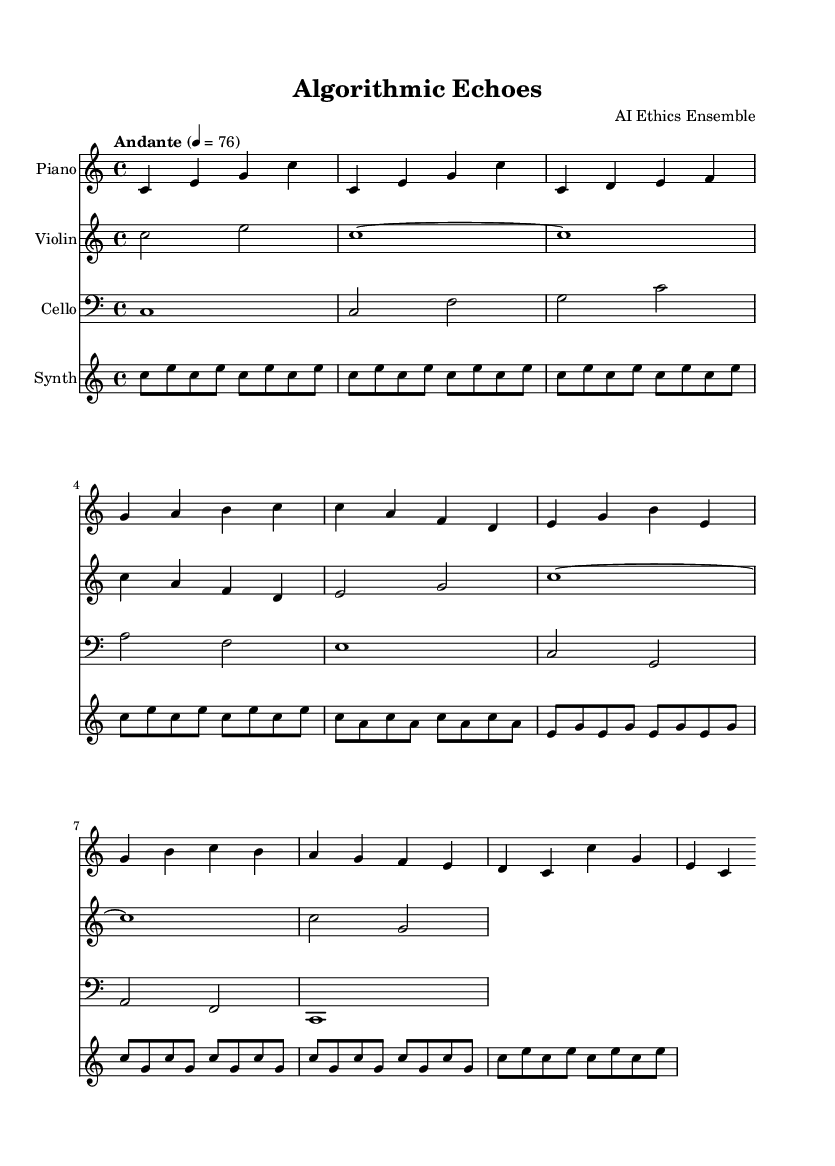What is the key signature of this music? The key signature is listed at the beginning of the score. It indicates C major, which has no sharps or flats.
Answer: C major What is the time signature of the piece? The time signature appears at the start of the music, indicating that it is in 4/4 time, which means there are four beats in each measure.
Answer: 4/4 What is the tempo marking? The tempo marking is found at the beginning of the score and specifies the pace of the piece as "Andante" with a metronome marking of 76 beats per minute.
Answer: Andante How many sections are in the composition? By analyzing the structure of the music, we see distinct sections labeled Intro, A, B, Interlude, A', and Outro, totaling six sections.
Answer: 6 What instruments are featured in this composition? The instruments are listed in the score under their respective staves, which include Piano, Violin, Cello, and Synth.
Answer: Piano, Violin, Cello, Synth Which section features a noticeable change in texture or harmony? The sections B and A' involve different notes compared to Section A, indicating changes in harmony and texture. Section B notably uses different pitches than the preceding sections.
Answer: Section B 